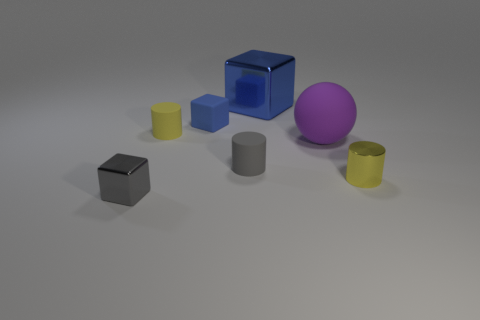Subtract all metal blocks. How many blocks are left? 1 Subtract all red cubes. How many yellow cylinders are left? 2 Add 1 large purple cylinders. How many objects exist? 8 Subtract all cubes. How many objects are left? 4 Subtract all red cylinders. Subtract all red spheres. How many cylinders are left? 3 Subtract all big blue metal blocks. Subtract all large blue cubes. How many objects are left? 5 Add 5 small blue rubber things. How many small blue rubber things are left? 6 Add 2 blue blocks. How many blue blocks exist? 4 Subtract 0 brown blocks. How many objects are left? 7 